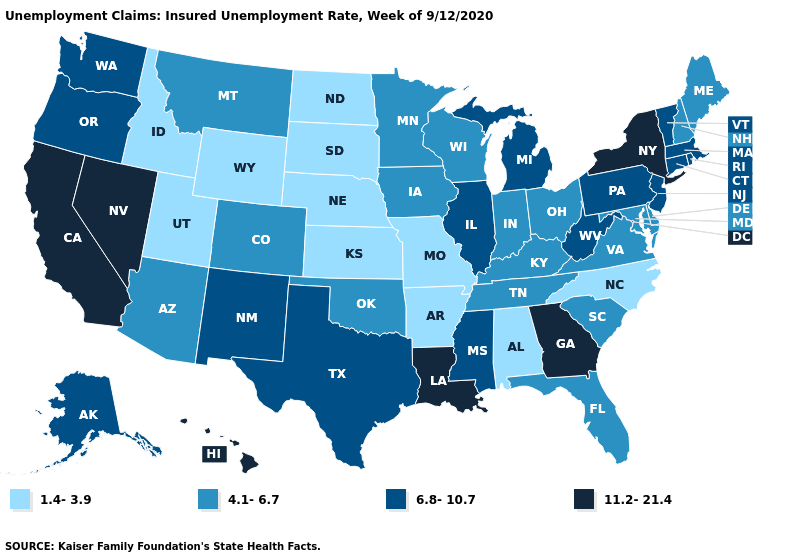Name the states that have a value in the range 6.8-10.7?
Concise answer only. Alaska, Connecticut, Illinois, Massachusetts, Michigan, Mississippi, New Jersey, New Mexico, Oregon, Pennsylvania, Rhode Island, Texas, Vermont, Washington, West Virginia. What is the value of Maryland?
Keep it brief. 4.1-6.7. Does Oregon have a lower value than Alabama?
Quick response, please. No. What is the value of Alaska?
Write a very short answer. 6.8-10.7. Does Delaware have the same value as Kentucky?
Write a very short answer. Yes. What is the value of Oregon?
Answer briefly. 6.8-10.7. Does Iowa have the lowest value in the MidWest?
Give a very brief answer. No. How many symbols are there in the legend?
Be succinct. 4. Does South Dakota have the lowest value in the USA?
Be succinct. Yes. Does Texas have the lowest value in the South?
Write a very short answer. No. Name the states that have a value in the range 6.8-10.7?
Give a very brief answer. Alaska, Connecticut, Illinois, Massachusetts, Michigan, Mississippi, New Jersey, New Mexico, Oregon, Pennsylvania, Rhode Island, Texas, Vermont, Washington, West Virginia. What is the value of Oklahoma?
Short answer required. 4.1-6.7. Does Idaho have the lowest value in the West?
Keep it brief. Yes. Does Oklahoma have a higher value than Utah?
Answer briefly. Yes. Which states have the lowest value in the USA?
Keep it brief. Alabama, Arkansas, Idaho, Kansas, Missouri, Nebraska, North Carolina, North Dakota, South Dakota, Utah, Wyoming. 